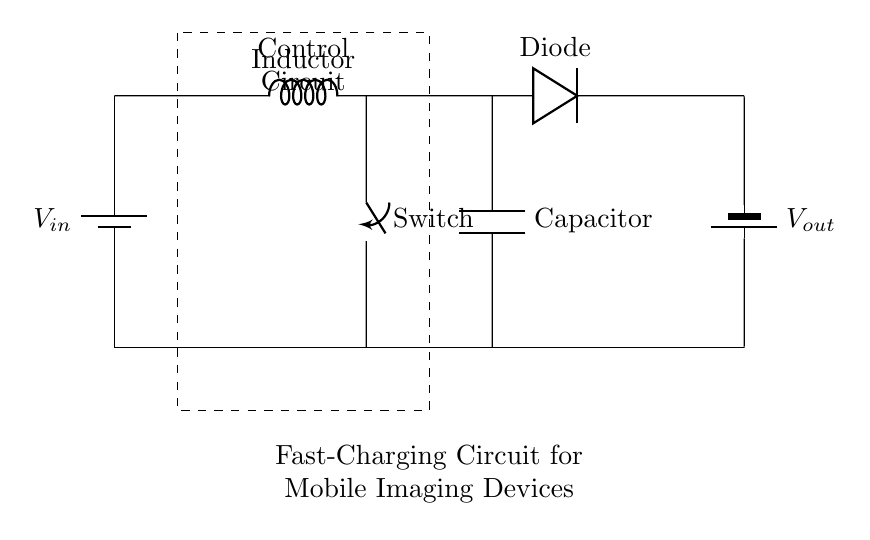What type of circuit is shown? The circuit is a fast-charging circuit for mobile imaging devices, evident from the labeled components and the context provided.
Answer: fast-charging circuit What is the role of the inductor in this circuit? The inductor is used to store energy and increase voltage, typically found in boost converters, which match the function of this circuit.
Answer: increase voltage What component is responsible for preventing backflow of current? The diode is responsible for preventing backflow, as it allows current to flow in only one direction, which is a fundamental property of diodes.
Answer: diode What is the output voltage of the circuit represented as? The output voltage is represented as V out, corresponding to the terminal connected to the battery, implying that it provides a specific voltage output.
Answer: V out How many main components are visible in this diagram? There are four main components (battery, inductor, diode, capacitor) that are clearly labeled and identifiable in the circuit diagram.
Answer: four What function does the capacitor serve in this circuit? The capacitor is used to smooth out the output voltage, ensuring a stable charge is provided to the battery, which is critical for fast-charging applications.
Answer: smooth output voltage What does the control circuit influence in this system? The control circuit regulates the charging process, managing when the energy flows to the battery, and is crucial for ensuring efficient charging.
Answer: regulate charging process 